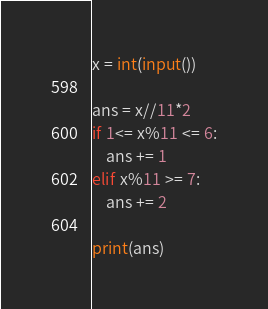Convert code to text. <code><loc_0><loc_0><loc_500><loc_500><_Python_>x = int(input())

ans = x//11*2
if 1<= x%11 <= 6:
    ans += 1
elif x%11 >= 7:
    ans += 2

print(ans)</code> 